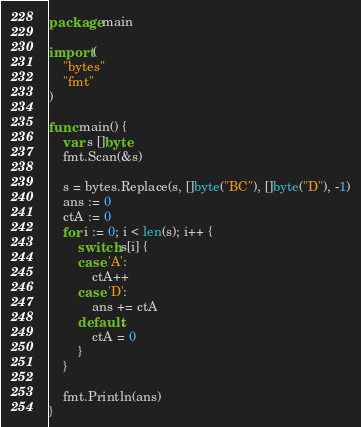<code> <loc_0><loc_0><loc_500><loc_500><_Go_>package main

import (
	"bytes"
	"fmt"
)

func main() {
	var s []byte
	fmt.Scan(&s)

	s = bytes.Replace(s, []byte("BC"), []byte("D"), -1)
	ans := 0
	ctA := 0
	for i := 0; i < len(s); i++ {
		switch s[i] {
		case 'A':
			ctA++
		case 'D':
			ans += ctA
		default:
			ctA = 0
		}
	}

	fmt.Println(ans)
}
</code> 